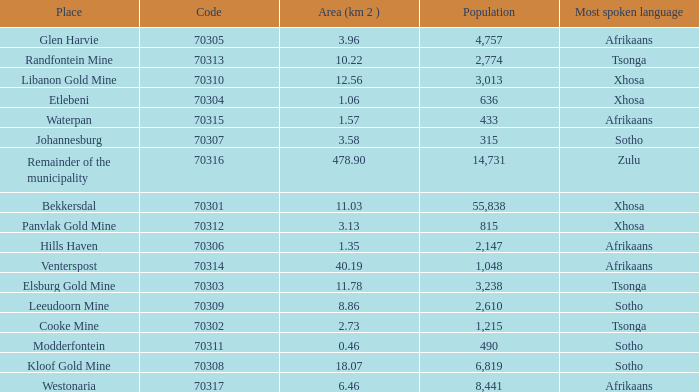What is the low code for glen harvie with a population greater than 2,774? 70305.0. 